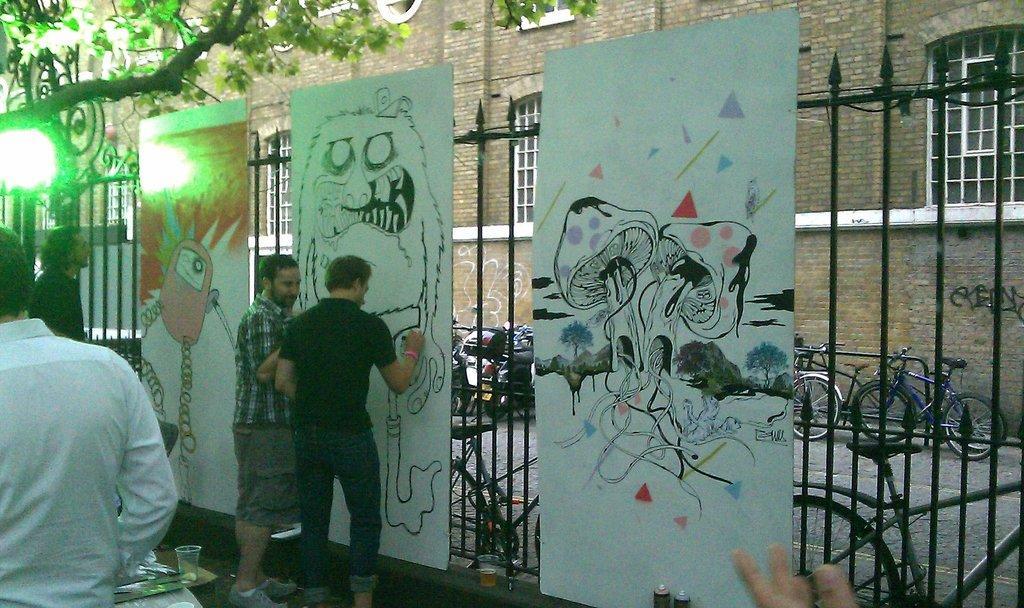Can you describe this image briefly? In the center of the image we can see two people standing and painting. There are painting boards. On the left there are two men. At the bottom we can see a table and things placed on the table. In the background there are bikes, bicycles, fence, tree and sky. 